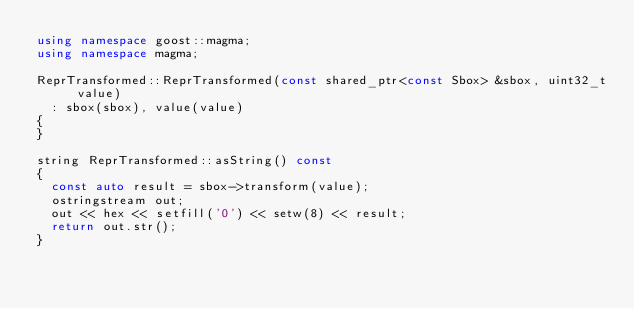Convert code to text. <code><loc_0><loc_0><loc_500><loc_500><_C++_>using namespace goost::magma;
using namespace magma;

ReprTransformed::ReprTransformed(const shared_ptr<const Sbox> &sbox, uint32_t value)
	: sbox(sbox), value(value)
{
}

string ReprTransformed::asString() const
{
	const auto result = sbox->transform(value);
	ostringstream out;
	out << hex << setfill('0') << setw(8) << result;
	return out.str();
}
</code> 